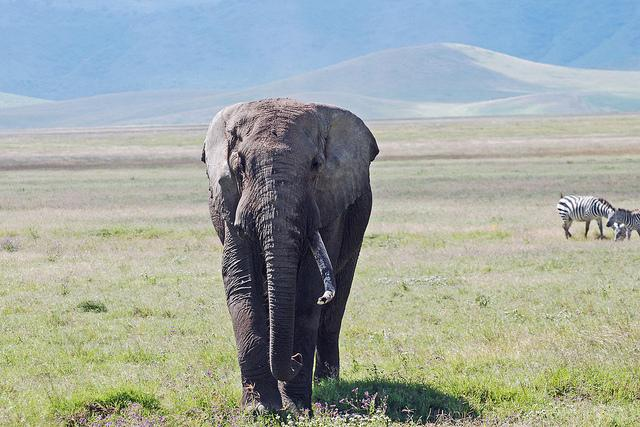What is the elephant missing on its right side?

Choices:
A) tusk
B) tail
C) beard
D) toe tusk 